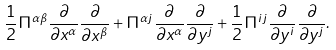<formula> <loc_0><loc_0><loc_500><loc_500>\frac { 1 } { 2 } \Pi ^ { \alpha \beta } \frac { \partial } { \partial x ^ { \alpha } } \frac { \partial } { \partial x ^ { \beta } } + \Pi ^ { \alpha j } \frac { \partial } { \partial x ^ { \alpha } } \frac { \partial } { \partial y ^ { j } } + \frac { 1 } { 2 } \Pi ^ { i j } \frac { \partial } { \partial y ^ { i } } \frac { \partial } { \partial y ^ { j } } .</formula> 